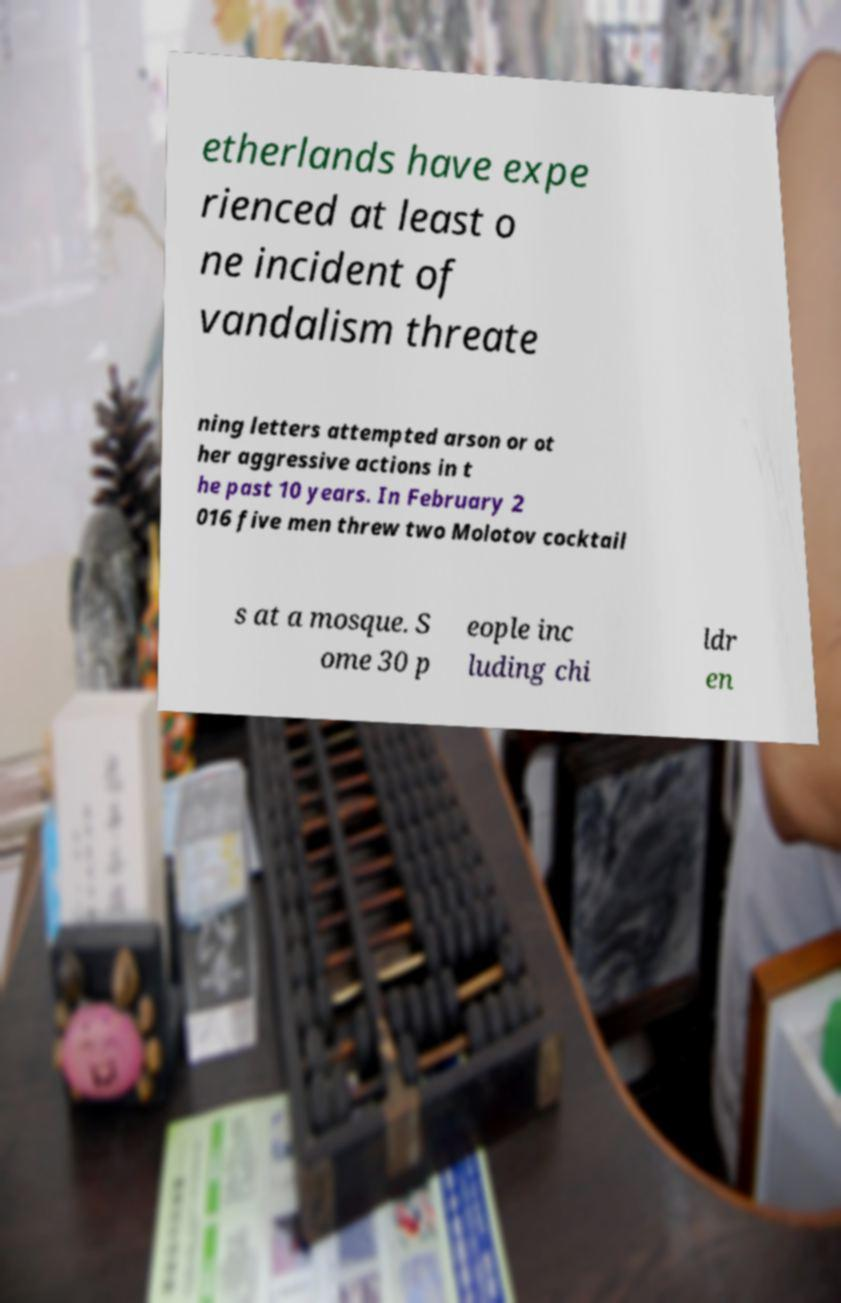What messages or text are displayed in this image? I need them in a readable, typed format. etherlands have expe rienced at least o ne incident of vandalism threate ning letters attempted arson or ot her aggressive actions in t he past 10 years. In February 2 016 five men threw two Molotov cocktail s at a mosque. S ome 30 p eople inc luding chi ldr en 